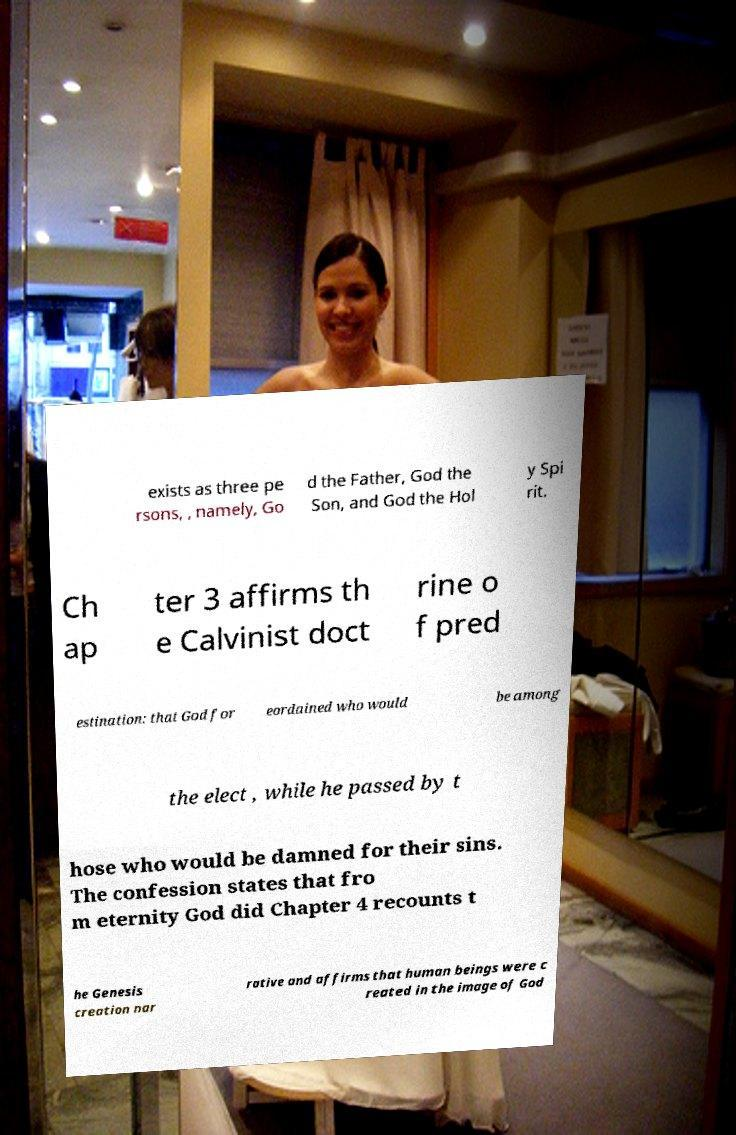Could you extract and type out the text from this image? exists as three pe rsons, , namely, Go d the Father, God the Son, and God the Hol y Spi rit. Ch ap ter 3 affirms th e Calvinist doct rine o f pred estination: that God for eordained who would be among the elect , while he passed by t hose who would be damned for their sins. The confession states that fro m eternity God did Chapter 4 recounts t he Genesis creation nar rative and affirms that human beings were c reated in the image of God 